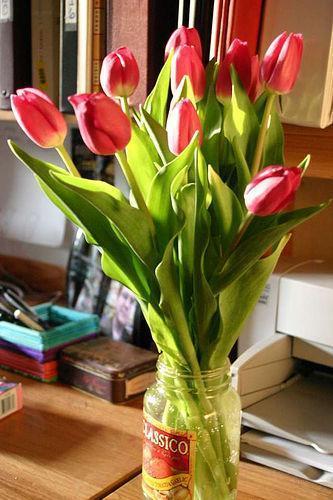How many flowers are there?
Give a very brief answer. 9. How many bottles are visible?
Give a very brief answer. 1. How many books are there?
Give a very brief answer. 2. How many of the boats in the front have yellow poles?
Give a very brief answer. 0. 